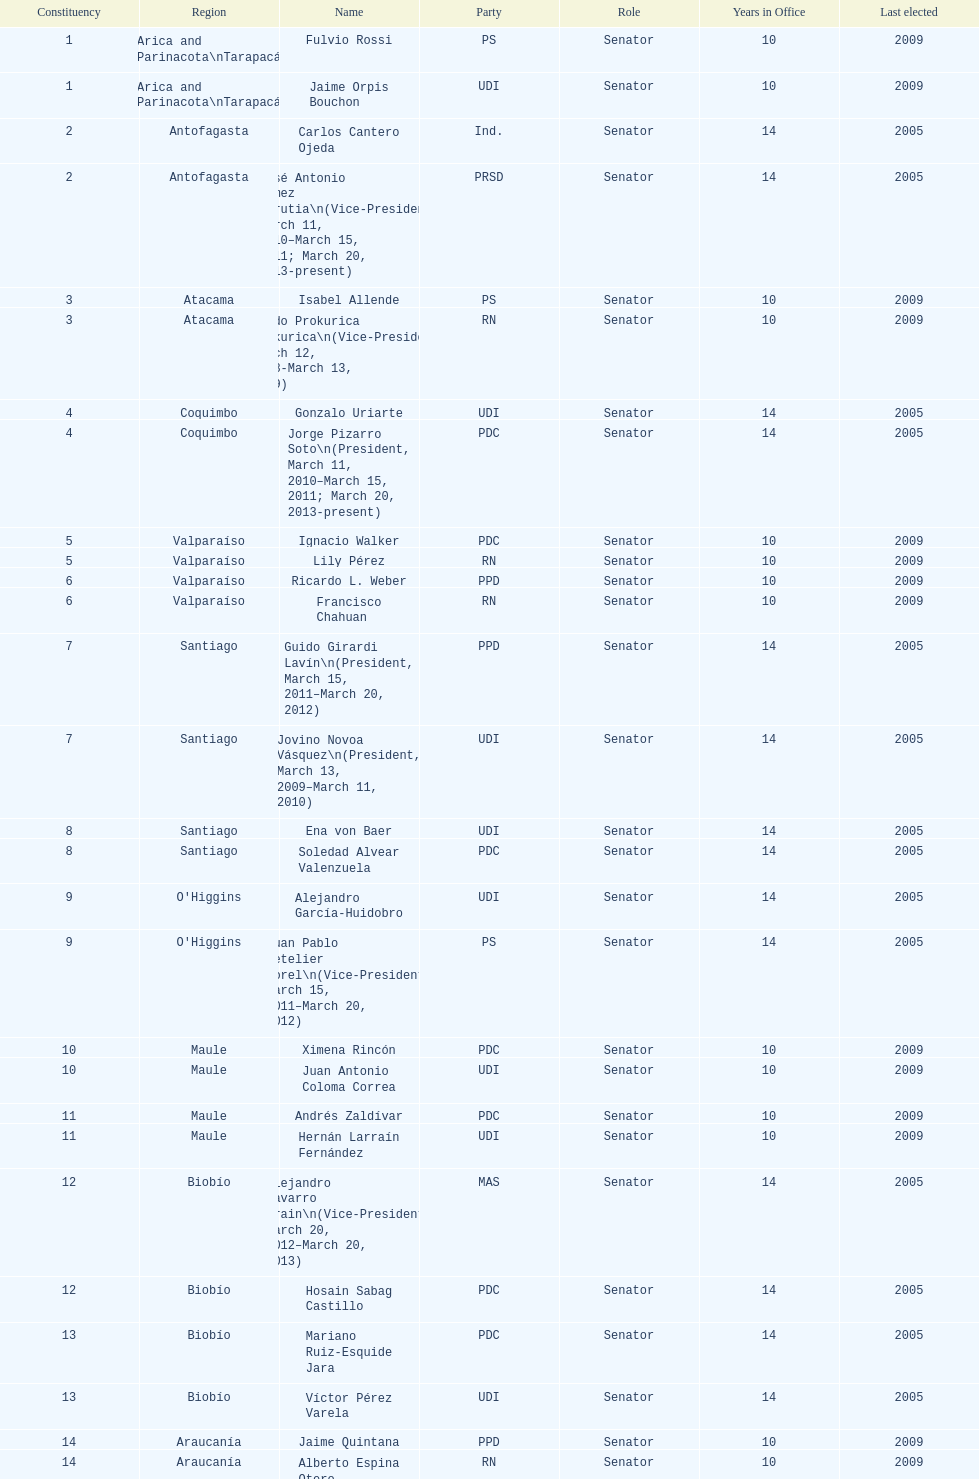Could you parse the entire table as a dict? {'header': ['Constituency', 'Region', 'Name', 'Party', 'Role', 'Years in Office', 'Last elected'], 'rows': [['1', 'Arica and Parinacota\\nTarapacá', 'Fulvio Rossi', 'PS', 'Senator', '10', '2009'], ['1', 'Arica and Parinacota\\nTarapacá', 'Jaime Orpis Bouchon', 'UDI', 'Senator', '10', '2009'], ['2', 'Antofagasta', 'Carlos Cantero Ojeda', 'Ind.', 'Senator', '14', '2005'], ['2', 'Antofagasta', 'José Antonio Gómez Urrutia\\n(Vice-President, March 11, 2010–March 15, 2011; March 20, 2013-present)', 'PRSD', 'Senator', '14', '2005'], ['3', 'Atacama', 'Isabel Allende', 'PS', 'Senator', '10', '2009'], ['3', 'Atacama', 'Baldo Prokurica Prokurica\\n(Vice-President, March 12, 2008-March 13, 2009)', 'RN', 'Senator', '10', '2009'], ['4', 'Coquimbo', 'Gonzalo Uriarte', 'UDI', 'Senator', '14', '2005'], ['4', 'Coquimbo', 'Jorge Pizarro Soto\\n(President, March 11, 2010–March 15, 2011; March 20, 2013-present)', 'PDC', 'Senator', '14', '2005'], ['5', 'Valparaíso', 'Ignacio Walker', 'PDC', 'Senator', '10', '2009'], ['5', 'Valparaíso', 'Lily Pérez', 'RN', 'Senator', '10', '2009'], ['6', 'Valparaíso', 'Ricardo L. Weber', 'PPD', 'Senator', '10', '2009'], ['6', 'Valparaíso', 'Francisco Chahuan', 'RN', 'Senator', '10', '2009'], ['7', 'Santiago', 'Guido Girardi Lavín\\n(President, March 15, 2011–March 20, 2012)', 'PPD', 'Senator', '14', '2005'], ['7', 'Santiago', 'Jovino Novoa Vásquez\\n(President, March 13, 2009–March 11, 2010)', 'UDI', 'Senator', '14', '2005'], ['8', 'Santiago', 'Ena von Baer', 'UDI', 'Senator', '14', '2005'], ['8', 'Santiago', 'Soledad Alvear Valenzuela', 'PDC', 'Senator', '14', '2005'], ['9', "O'Higgins", 'Alejandro García-Huidobro', 'UDI', 'Senator', '14', '2005'], ['9', "O'Higgins", 'Juan Pablo Letelier Morel\\n(Vice-President, March 15, 2011–March 20, 2012)', 'PS', 'Senator', '14', '2005'], ['10', 'Maule', 'Ximena Rincón', 'PDC', 'Senator', '10', '2009'], ['10', 'Maule', 'Juan Antonio Coloma Correa', 'UDI', 'Senator', '10', '2009'], ['11', 'Maule', 'Andrés Zaldívar', 'PDC', 'Senator', '10', '2009'], ['11', 'Maule', 'Hernán Larraín Fernández', 'UDI', 'Senator', '10', '2009'], ['12', 'Biobío', 'Alejandro Navarro Brain\\n(Vice-President, March 20, 2012–March 20, 2013)', 'MAS', 'Senator', '14', '2005'], ['12', 'Biobío', 'Hosain Sabag Castillo', 'PDC', 'Senator', '14', '2005'], ['13', 'Biobío', 'Mariano Ruiz-Esquide Jara', 'PDC', 'Senator', '14', '2005'], ['13', 'Biobío', 'Víctor Pérez Varela', 'UDI', 'Senator', '14', '2005'], ['14', 'Araucanía', 'Jaime Quintana', 'PPD', 'Senator', '10', '2009'], ['14', 'Araucanía', 'Alberto Espina Otero', 'RN', 'Senator', '10', '2009'], ['15', 'Araucanía', 'Eugenio Tuma', 'PPD', 'Senator', '10', '2009'], ['15', 'Araucanía', 'José García Ruminot', 'RN', 'Senator', '10', '2009'], ['16', 'Los Ríos\\n(plus District 55)', 'Carlos Larraín Peña', 'RN', 'Senator', '14', '2005'], ['16', 'Los Ríos\\n(plus District 55)', 'Eduardo Frei Ruiz-Tagle\\n(President, March 11, 2006-March 12, 2008)', 'PDC', 'Senator', '14', '2005'], ['17', 'Los Lagos\\n(minus District 55)', 'Camilo Escalona Medina\\n(President, March 20, 2012–March 20, 2013)', 'PS', 'Senator', '14', '2005'], ['17', 'Los Lagos\\n(minus District 55)', 'Carlos Kuschel Silva', 'RN', 'Senator', '14', '2005'], ['18', 'Aisén', 'Patricio Walker', 'PDC', 'Senator', '10', '2009'], ['18', 'Aisén', 'Antonio Horvath Kiss', 'RN', 'Senator', '18', '2001'], ['19', 'Magallanes', 'Carlos Bianchi Chelech\\n(Vice-President, March 13, 2009–March 11, 2010)', 'Ind.', 'Senator', '14', '2005'], ['19', 'Magallanes', 'Pedro Muñoz Aburto', 'PS', 'Senator', '14', '2005']]} What is the last region listed on the table? Magallanes. 